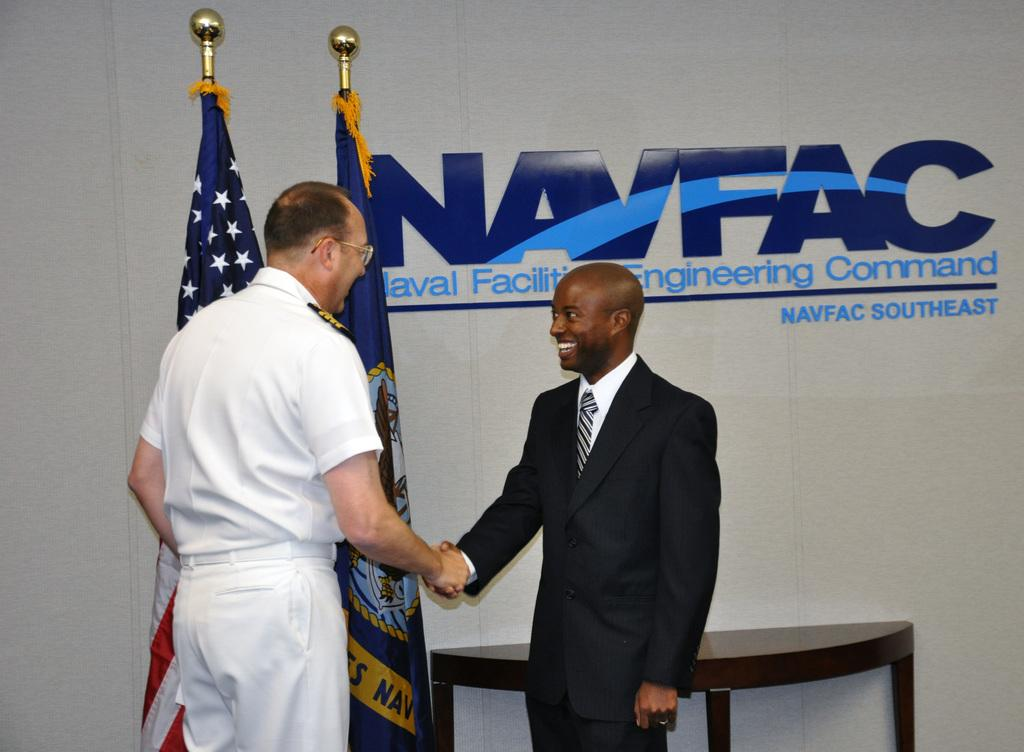Provide a one-sentence caption for the provided image. Two men shake hands in front of a NAVFAC sign. 